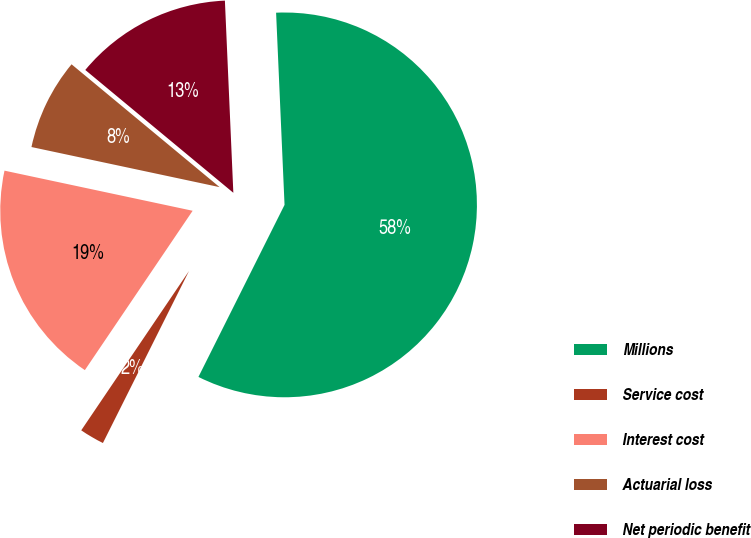Convert chart. <chart><loc_0><loc_0><loc_500><loc_500><pie_chart><fcel>Millions<fcel>Service cost<fcel>Interest cost<fcel>Actuarial loss<fcel>Net periodic benefit<nl><fcel>58.09%<fcel>2.08%<fcel>18.88%<fcel>7.68%<fcel>13.28%<nl></chart> 